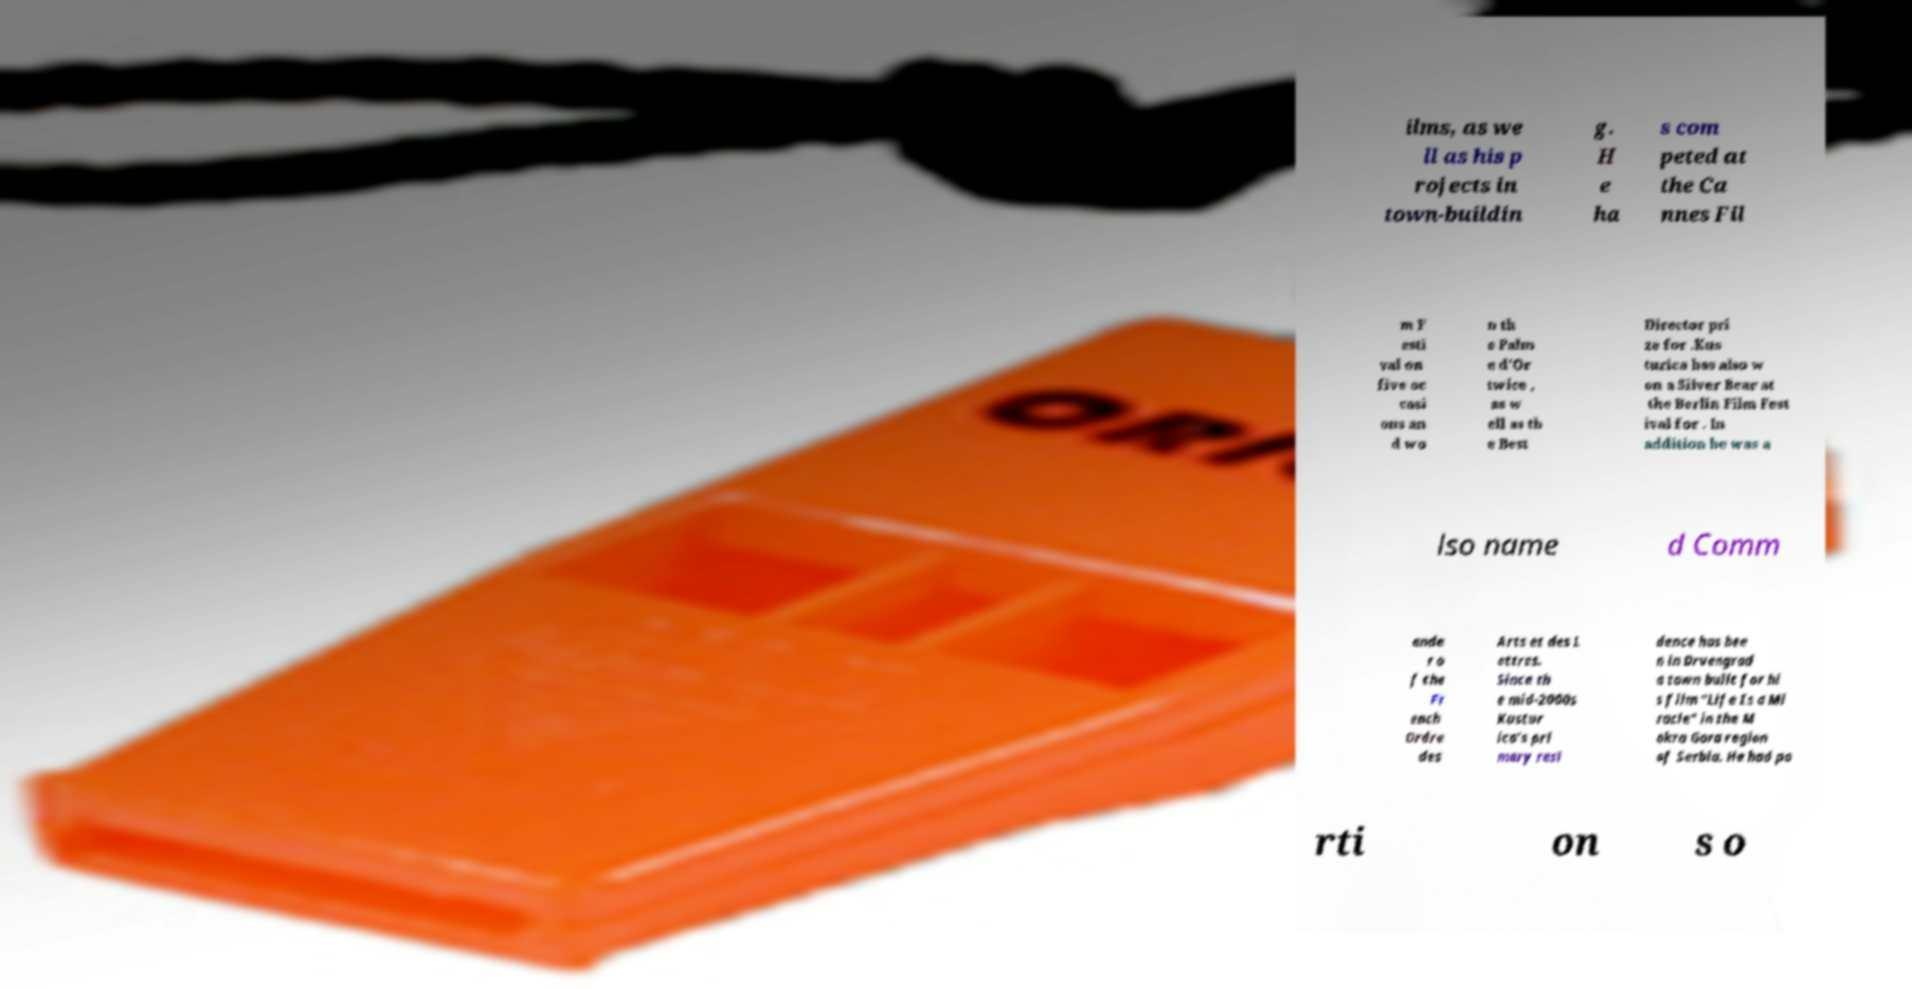What messages or text are displayed in this image? I need them in a readable, typed format. ilms, as we ll as his p rojects in town-buildin g. H e ha s com peted at the Ca nnes Fil m F esti val on five oc casi ons an d wo n th e Palm e d'Or twice , as w ell as th e Best Director pri ze for .Kus turica has also w on a Silver Bear at the Berlin Film Fest ival for . In addition he was a lso name d Comm ande r o f the Fr ench Ordre des Arts et des L ettres. Since th e mid-2000s Kustur ica's pri mary resi dence has bee n in Drvengrad a town built for hi s film "Life Is a Mi racle" in the M okra Gora region of Serbia. He had po rti on s o 